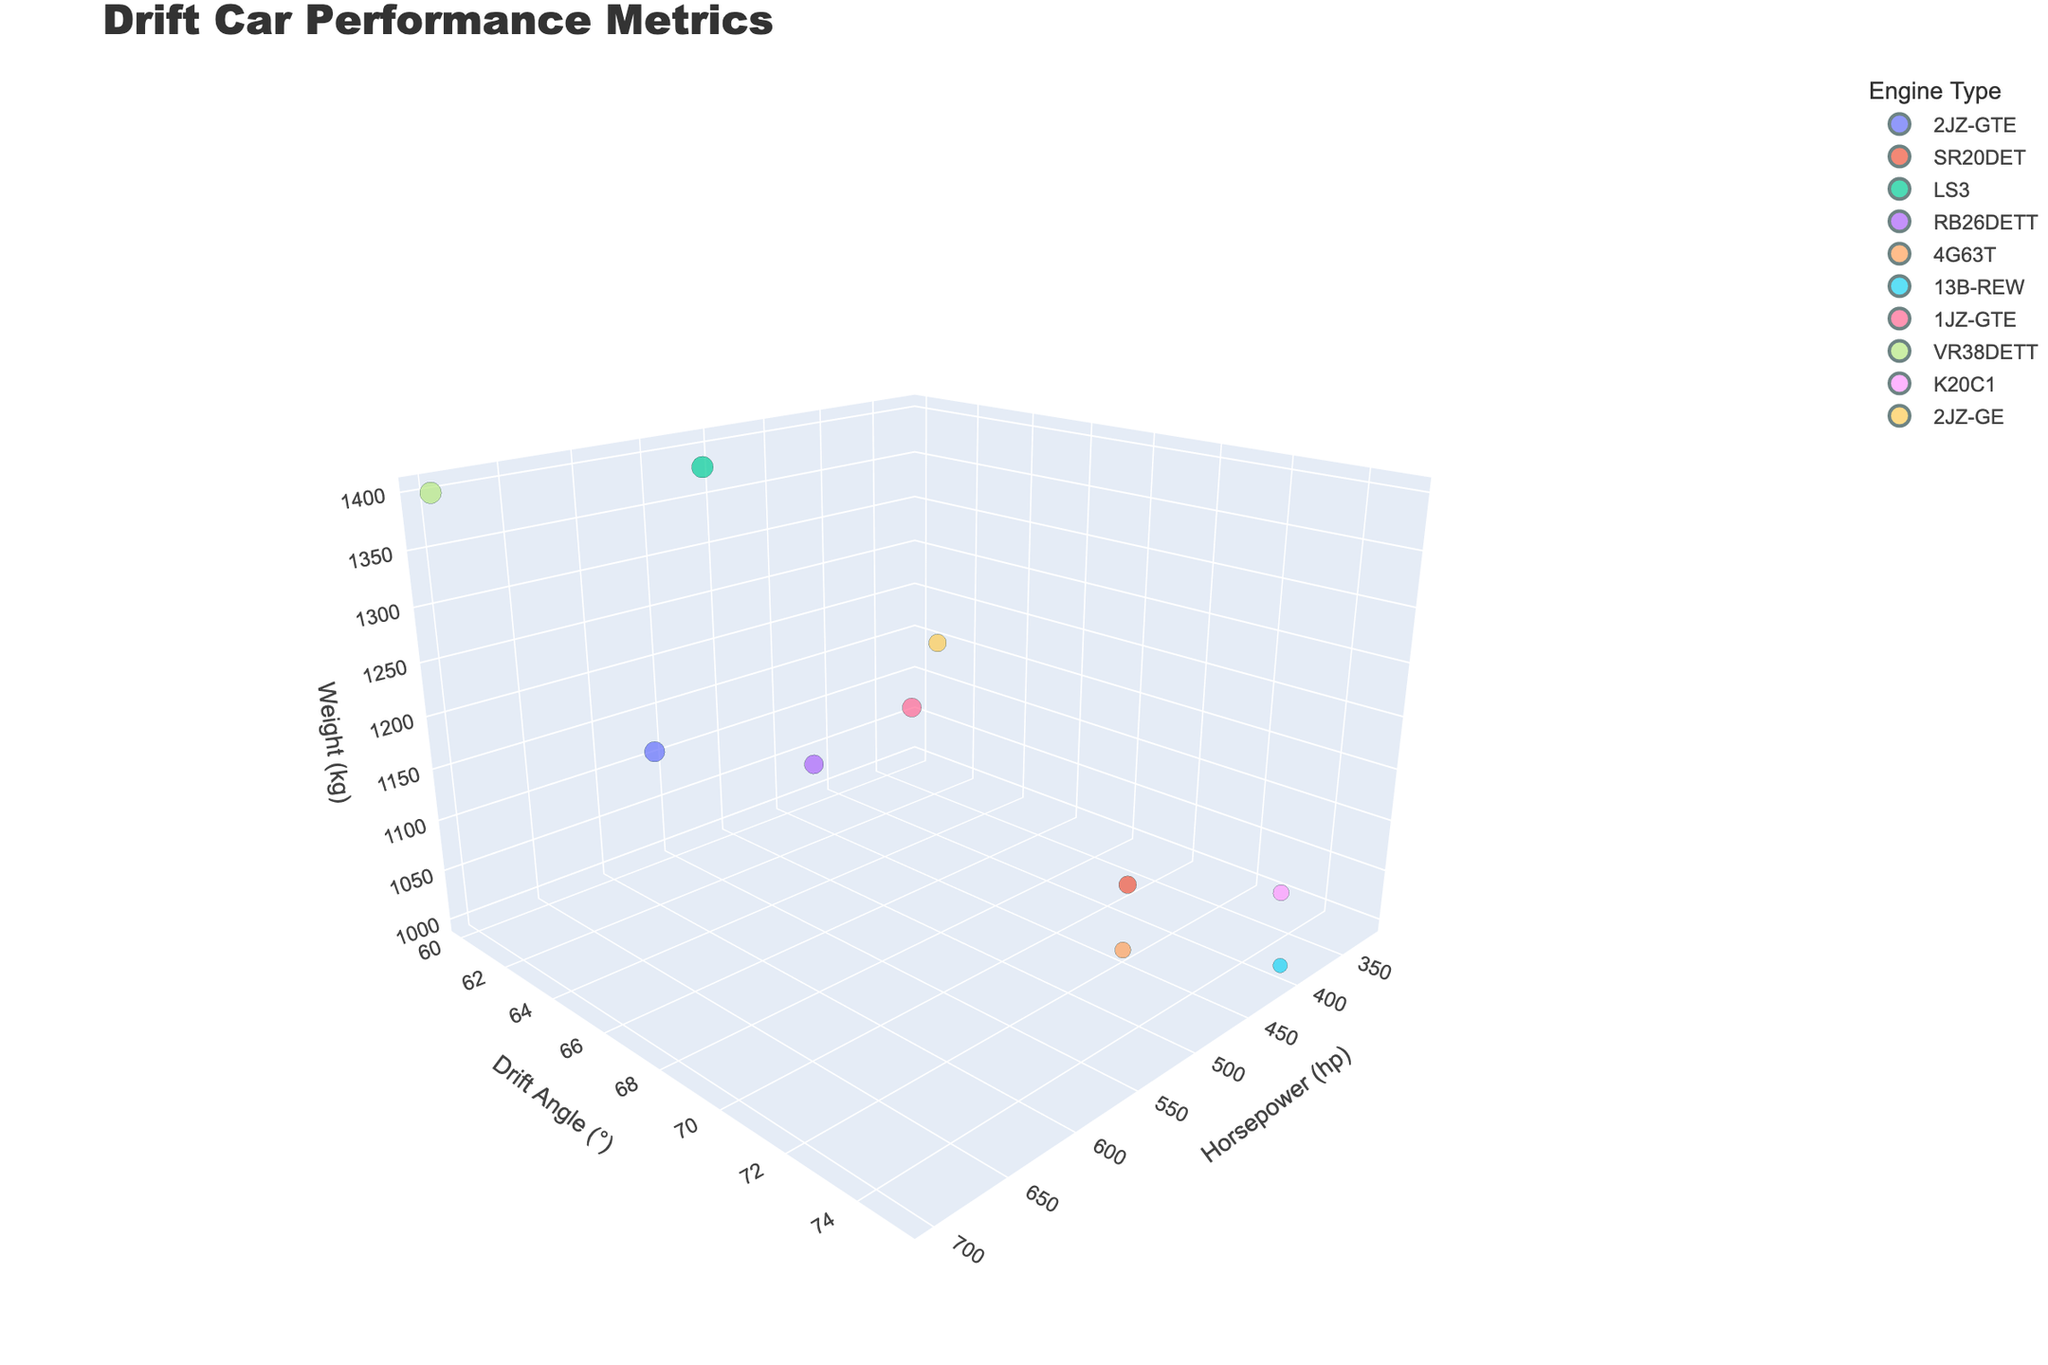How many data points are represented in the chart? Counting the number of different bubbles on the 3D bubble chart will give you the total number of data points. Each bubble represents one set of performance metrics for a drift car.
Answer: 10 Which engine type has the highest horsepower in this chart? Look for the bubble that has the highest value on the horsepower (x) axis and identify its corresponding engine type from the legend or hover information.
Answer: VR38DETT What is the maximum drift angle recorded in the chart, and which tire compound achieves this? Identify which bubble is positioned highest along the y-axis (drift angle), and use the hover name to find the tire compound associated with it.
Answer: 75, Hankook Ventus R-S4 Compare the smoke generation of the two drift cars with the LS3 and VR38DETT engines. Which one generates more smoke? Check the sizes of the bubbles for both the LS3 and VR38DETT engines. The larger bubble indicates higher smoke generation.
Answer: VR38DETT Which weight class generally shows a higher drift angle, 1000-1200 kg or 1400-1600 kg? Analyze the position along the y-axis (drift angle) for bubbles in the 1000-1200 kg weight class versus those in the 1400-1600 kg weight class to determine which class generally shows a higher angle.
Answer: 1000-1200 kg What is the average horsepower for cars in the 1200-1400 kg weight class? Find the bubbles within the 1200-1400 kg weight class along the z-axis, sum up their horsepower values, and then divide the sum by the number of data points in this weight class.
Answer: (650 + 600 + 500 + 400) / 4 = 537.5 Do cars with higher horsepower always produce more smoke? Compare the sizes (representing smoke generation) of the bubbles with higher horsepower values against those with lower horsepower values to see if there's a consistent trend.
Answer: No What is the range of drift angles for cars using a Falken Azenis RT660 tire compound? Look at the specific bubble for the Falken Azenis RT660 tire compound and note its position along the y-axis (drift angle). As there's only one data point for this tire, the range is singular.
Answer: 70 For the car with the 13B-REW engine, how much lower is its horsepower compared to the car with the K20C1 engine? Locate the bubbles for the 13B-REW and K20C1 engines and note their horsepower values. Calculate the difference between these values.
Answer: 400 - 320 = 80 